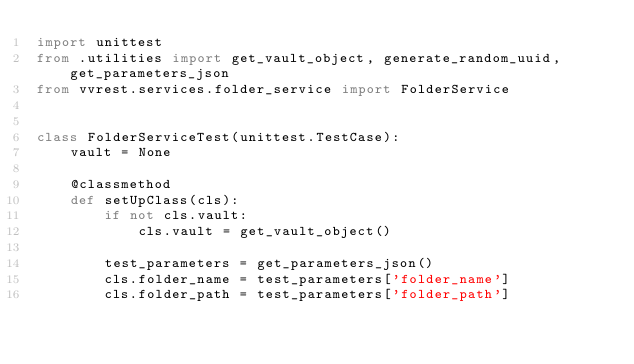Convert code to text. <code><loc_0><loc_0><loc_500><loc_500><_Python_>import unittest
from .utilities import get_vault_object, generate_random_uuid, get_parameters_json
from vvrest.services.folder_service import FolderService


class FolderServiceTest(unittest.TestCase):
    vault = None

    @classmethod
    def setUpClass(cls):
        if not cls.vault:
            cls.vault = get_vault_object()

        test_parameters = get_parameters_json()
        cls.folder_name = test_parameters['folder_name']
        cls.folder_path = test_parameters['folder_path']</code> 